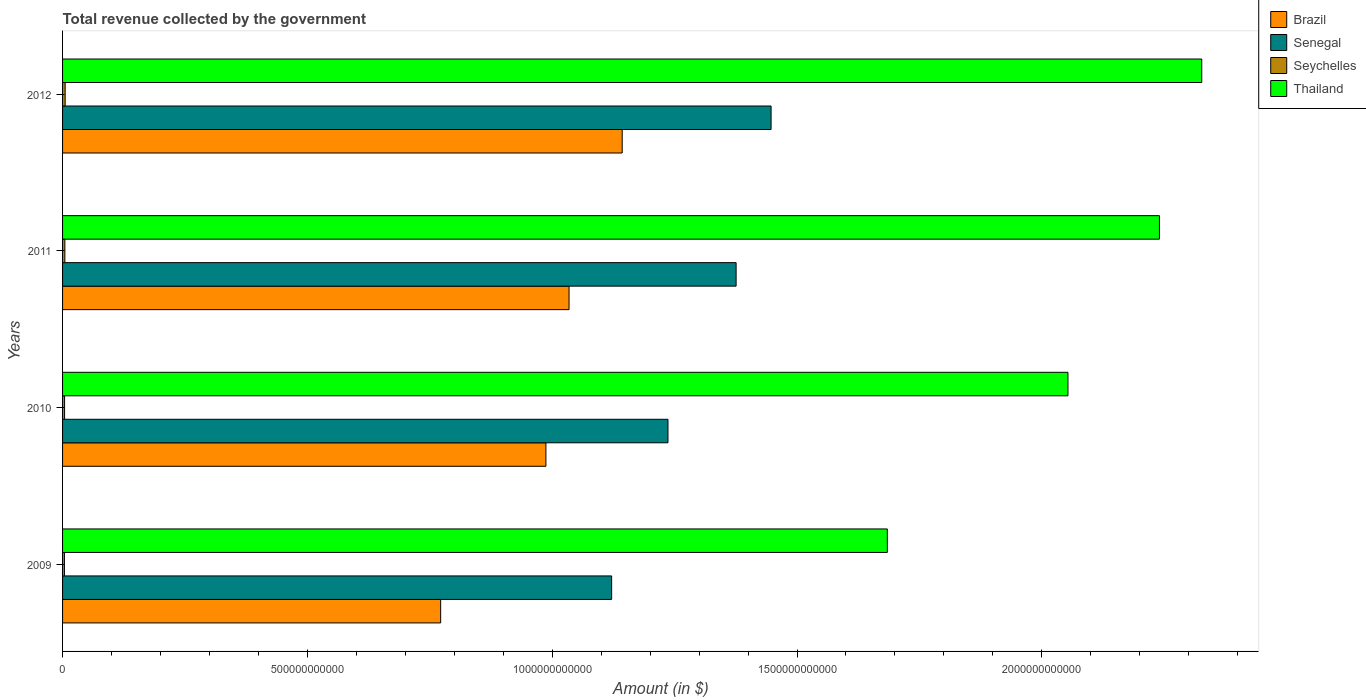How many different coloured bars are there?
Your response must be concise. 4. Are the number of bars on each tick of the Y-axis equal?
Give a very brief answer. Yes. How many bars are there on the 3rd tick from the bottom?
Provide a succinct answer. 4. What is the label of the 3rd group of bars from the top?
Offer a very short reply. 2010. What is the total revenue collected by the government in Thailand in 2012?
Your answer should be very brief. 2.33e+12. Across all years, what is the maximum total revenue collected by the government in Senegal?
Provide a succinct answer. 1.45e+12. Across all years, what is the minimum total revenue collected by the government in Brazil?
Your answer should be compact. 7.72e+11. In which year was the total revenue collected by the government in Seychelles maximum?
Give a very brief answer. 2012. What is the total total revenue collected by the government in Senegal in the graph?
Your answer should be very brief. 5.18e+12. What is the difference between the total revenue collected by the government in Senegal in 2011 and that in 2012?
Give a very brief answer. -7.14e+1. What is the difference between the total revenue collected by the government in Senegal in 2009 and the total revenue collected by the government in Thailand in 2012?
Make the answer very short. -1.21e+12. What is the average total revenue collected by the government in Thailand per year?
Your response must be concise. 2.08e+12. In the year 2009, what is the difference between the total revenue collected by the government in Seychelles and total revenue collected by the government in Thailand?
Your answer should be very brief. -1.68e+12. In how many years, is the total revenue collected by the government in Brazil greater than 200000000000 $?
Keep it short and to the point. 4. What is the ratio of the total revenue collected by the government in Senegal in 2010 to that in 2012?
Ensure brevity in your answer.  0.85. Is the total revenue collected by the government in Seychelles in 2009 less than that in 2012?
Provide a succinct answer. Yes. Is the difference between the total revenue collected by the government in Seychelles in 2010 and 2011 greater than the difference between the total revenue collected by the government in Thailand in 2010 and 2011?
Provide a short and direct response. Yes. What is the difference between the highest and the second highest total revenue collected by the government in Brazil?
Offer a terse response. 1.09e+11. What is the difference between the highest and the lowest total revenue collected by the government in Thailand?
Your response must be concise. 6.42e+11. In how many years, is the total revenue collected by the government in Brazil greater than the average total revenue collected by the government in Brazil taken over all years?
Offer a very short reply. 3. Is it the case that in every year, the sum of the total revenue collected by the government in Thailand and total revenue collected by the government in Brazil is greater than the sum of total revenue collected by the government in Seychelles and total revenue collected by the government in Senegal?
Give a very brief answer. No. What does the 2nd bar from the top in 2012 represents?
Make the answer very short. Seychelles. What does the 3rd bar from the bottom in 2011 represents?
Your response must be concise. Seychelles. Is it the case that in every year, the sum of the total revenue collected by the government in Senegal and total revenue collected by the government in Thailand is greater than the total revenue collected by the government in Seychelles?
Ensure brevity in your answer.  Yes. How many years are there in the graph?
Give a very brief answer. 4. What is the difference between two consecutive major ticks on the X-axis?
Make the answer very short. 5.00e+11. Are the values on the major ticks of X-axis written in scientific E-notation?
Your answer should be very brief. No. Does the graph contain any zero values?
Your answer should be compact. No. How many legend labels are there?
Provide a short and direct response. 4. What is the title of the graph?
Ensure brevity in your answer.  Total revenue collected by the government. Does "Dominican Republic" appear as one of the legend labels in the graph?
Your answer should be very brief. No. What is the label or title of the X-axis?
Give a very brief answer. Amount (in $). What is the Amount (in $) in Brazil in 2009?
Provide a short and direct response. 7.72e+11. What is the Amount (in $) in Senegal in 2009?
Offer a very short reply. 1.12e+12. What is the Amount (in $) of Seychelles in 2009?
Your response must be concise. 3.81e+09. What is the Amount (in $) in Thailand in 2009?
Your answer should be compact. 1.68e+12. What is the Amount (in $) of Brazil in 2010?
Give a very brief answer. 9.87e+11. What is the Amount (in $) in Senegal in 2010?
Offer a very short reply. 1.24e+12. What is the Amount (in $) in Seychelles in 2010?
Your response must be concise. 4.11e+09. What is the Amount (in $) of Thailand in 2010?
Provide a short and direct response. 2.05e+12. What is the Amount (in $) in Brazil in 2011?
Your answer should be very brief. 1.03e+12. What is the Amount (in $) of Senegal in 2011?
Your response must be concise. 1.38e+12. What is the Amount (in $) in Seychelles in 2011?
Give a very brief answer. 4.69e+09. What is the Amount (in $) in Thailand in 2011?
Offer a terse response. 2.24e+12. What is the Amount (in $) in Brazil in 2012?
Your response must be concise. 1.14e+12. What is the Amount (in $) in Senegal in 2012?
Provide a short and direct response. 1.45e+12. What is the Amount (in $) in Seychelles in 2012?
Provide a short and direct response. 5.30e+09. What is the Amount (in $) in Thailand in 2012?
Your response must be concise. 2.33e+12. Across all years, what is the maximum Amount (in $) in Brazil?
Give a very brief answer. 1.14e+12. Across all years, what is the maximum Amount (in $) in Senegal?
Give a very brief answer. 1.45e+12. Across all years, what is the maximum Amount (in $) in Seychelles?
Keep it short and to the point. 5.30e+09. Across all years, what is the maximum Amount (in $) of Thailand?
Provide a short and direct response. 2.33e+12. Across all years, what is the minimum Amount (in $) in Brazil?
Offer a terse response. 7.72e+11. Across all years, what is the minimum Amount (in $) of Senegal?
Give a very brief answer. 1.12e+12. Across all years, what is the minimum Amount (in $) in Seychelles?
Give a very brief answer. 3.81e+09. Across all years, what is the minimum Amount (in $) of Thailand?
Make the answer very short. 1.68e+12. What is the total Amount (in $) in Brazil in the graph?
Provide a short and direct response. 3.94e+12. What is the total Amount (in $) of Senegal in the graph?
Offer a very short reply. 5.18e+12. What is the total Amount (in $) in Seychelles in the graph?
Keep it short and to the point. 1.79e+1. What is the total Amount (in $) in Thailand in the graph?
Keep it short and to the point. 8.30e+12. What is the difference between the Amount (in $) in Brazil in 2009 and that in 2010?
Provide a short and direct response. -2.15e+11. What is the difference between the Amount (in $) in Senegal in 2009 and that in 2010?
Your response must be concise. -1.15e+11. What is the difference between the Amount (in $) of Seychelles in 2009 and that in 2010?
Keep it short and to the point. -3.04e+08. What is the difference between the Amount (in $) of Thailand in 2009 and that in 2010?
Make the answer very short. -3.69e+11. What is the difference between the Amount (in $) in Brazil in 2009 and that in 2011?
Give a very brief answer. -2.62e+11. What is the difference between the Amount (in $) of Senegal in 2009 and that in 2011?
Your response must be concise. -2.54e+11. What is the difference between the Amount (in $) of Seychelles in 2009 and that in 2011?
Make the answer very short. -8.79e+08. What is the difference between the Amount (in $) of Thailand in 2009 and that in 2011?
Provide a succinct answer. -5.56e+11. What is the difference between the Amount (in $) of Brazil in 2009 and that in 2012?
Keep it short and to the point. -3.71e+11. What is the difference between the Amount (in $) in Senegal in 2009 and that in 2012?
Offer a terse response. -3.26e+11. What is the difference between the Amount (in $) of Seychelles in 2009 and that in 2012?
Your response must be concise. -1.49e+09. What is the difference between the Amount (in $) in Thailand in 2009 and that in 2012?
Offer a terse response. -6.42e+11. What is the difference between the Amount (in $) of Brazil in 2010 and that in 2011?
Your response must be concise. -4.72e+1. What is the difference between the Amount (in $) of Senegal in 2010 and that in 2011?
Keep it short and to the point. -1.39e+11. What is the difference between the Amount (in $) in Seychelles in 2010 and that in 2011?
Your response must be concise. -5.75e+08. What is the difference between the Amount (in $) in Thailand in 2010 and that in 2011?
Provide a short and direct response. -1.87e+11. What is the difference between the Amount (in $) of Brazil in 2010 and that in 2012?
Your response must be concise. -1.56e+11. What is the difference between the Amount (in $) in Senegal in 2010 and that in 2012?
Keep it short and to the point. -2.11e+11. What is the difference between the Amount (in $) in Seychelles in 2010 and that in 2012?
Your answer should be very brief. -1.19e+09. What is the difference between the Amount (in $) in Thailand in 2010 and that in 2012?
Keep it short and to the point. -2.73e+11. What is the difference between the Amount (in $) of Brazil in 2011 and that in 2012?
Offer a terse response. -1.09e+11. What is the difference between the Amount (in $) of Senegal in 2011 and that in 2012?
Your answer should be very brief. -7.14e+1. What is the difference between the Amount (in $) in Seychelles in 2011 and that in 2012?
Keep it short and to the point. -6.15e+08. What is the difference between the Amount (in $) in Thailand in 2011 and that in 2012?
Make the answer very short. -8.64e+1. What is the difference between the Amount (in $) of Brazil in 2009 and the Amount (in $) of Senegal in 2010?
Your answer should be very brief. -4.64e+11. What is the difference between the Amount (in $) in Brazil in 2009 and the Amount (in $) in Seychelles in 2010?
Keep it short and to the point. 7.68e+11. What is the difference between the Amount (in $) in Brazil in 2009 and the Amount (in $) in Thailand in 2010?
Give a very brief answer. -1.28e+12. What is the difference between the Amount (in $) of Senegal in 2009 and the Amount (in $) of Seychelles in 2010?
Give a very brief answer. 1.12e+12. What is the difference between the Amount (in $) in Senegal in 2009 and the Amount (in $) in Thailand in 2010?
Ensure brevity in your answer.  -9.32e+11. What is the difference between the Amount (in $) of Seychelles in 2009 and the Amount (in $) of Thailand in 2010?
Offer a terse response. -2.05e+12. What is the difference between the Amount (in $) in Brazil in 2009 and the Amount (in $) in Senegal in 2011?
Keep it short and to the point. -6.03e+11. What is the difference between the Amount (in $) of Brazil in 2009 and the Amount (in $) of Seychelles in 2011?
Your answer should be very brief. 7.67e+11. What is the difference between the Amount (in $) of Brazil in 2009 and the Amount (in $) of Thailand in 2011?
Offer a very short reply. -1.47e+12. What is the difference between the Amount (in $) in Senegal in 2009 and the Amount (in $) in Seychelles in 2011?
Your response must be concise. 1.12e+12. What is the difference between the Amount (in $) in Senegal in 2009 and the Amount (in $) in Thailand in 2011?
Ensure brevity in your answer.  -1.12e+12. What is the difference between the Amount (in $) in Seychelles in 2009 and the Amount (in $) in Thailand in 2011?
Keep it short and to the point. -2.24e+12. What is the difference between the Amount (in $) of Brazil in 2009 and the Amount (in $) of Senegal in 2012?
Keep it short and to the point. -6.75e+11. What is the difference between the Amount (in $) of Brazil in 2009 and the Amount (in $) of Seychelles in 2012?
Give a very brief answer. 7.67e+11. What is the difference between the Amount (in $) in Brazil in 2009 and the Amount (in $) in Thailand in 2012?
Offer a very short reply. -1.55e+12. What is the difference between the Amount (in $) in Senegal in 2009 and the Amount (in $) in Seychelles in 2012?
Give a very brief answer. 1.12e+12. What is the difference between the Amount (in $) in Senegal in 2009 and the Amount (in $) in Thailand in 2012?
Ensure brevity in your answer.  -1.21e+12. What is the difference between the Amount (in $) of Seychelles in 2009 and the Amount (in $) of Thailand in 2012?
Keep it short and to the point. -2.32e+12. What is the difference between the Amount (in $) in Brazil in 2010 and the Amount (in $) in Senegal in 2011?
Your answer should be compact. -3.88e+11. What is the difference between the Amount (in $) of Brazil in 2010 and the Amount (in $) of Seychelles in 2011?
Ensure brevity in your answer.  9.82e+11. What is the difference between the Amount (in $) in Brazil in 2010 and the Amount (in $) in Thailand in 2011?
Your answer should be very brief. -1.25e+12. What is the difference between the Amount (in $) in Senegal in 2010 and the Amount (in $) in Seychelles in 2011?
Your answer should be compact. 1.23e+12. What is the difference between the Amount (in $) in Senegal in 2010 and the Amount (in $) in Thailand in 2011?
Keep it short and to the point. -1.00e+12. What is the difference between the Amount (in $) in Seychelles in 2010 and the Amount (in $) in Thailand in 2011?
Offer a terse response. -2.24e+12. What is the difference between the Amount (in $) in Brazil in 2010 and the Amount (in $) in Senegal in 2012?
Offer a very short reply. -4.60e+11. What is the difference between the Amount (in $) in Brazil in 2010 and the Amount (in $) in Seychelles in 2012?
Provide a short and direct response. 9.82e+11. What is the difference between the Amount (in $) of Brazil in 2010 and the Amount (in $) of Thailand in 2012?
Offer a terse response. -1.34e+12. What is the difference between the Amount (in $) in Senegal in 2010 and the Amount (in $) in Seychelles in 2012?
Offer a terse response. 1.23e+12. What is the difference between the Amount (in $) of Senegal in 2010 and the Amount (in $) of Thailand in 2012?
Provide a short and direct response. -1.09e+12. What is the difference between the Amount (in $) of Seychelles in 2010 and the Amount (in $) of Thailand in 2012?
Offer a very short reply. -2.32e+12. What is the difference between the Amount (in $) in Brazil in 2011 and the Amount (in $) in Senegal in 2012?
Keep it short and to the point. -4.13e+11. What is the difference between the Amount (in $) in Brazil in 2011 and the Amount (in $) in Seychelles in 2012?
Provide a succinct answer. 1.03e+12. What is the difference between the Amount (in $) in Brazil in 2011 and the Amount (in $) in Thailand in 2012?
Offer a terse response. -1.29e+12. What is the difference between the Amount (in $) of Senegal in 2011 and the Amount (in $) of Seychelles in 2012?
Offer a very short reply. 1.37e+12. What is the difference between the Amount (in $) in Senegal in 2011 and the Amount (in $) in Thailand in 2012?
Offer a very short reply. -9.51e+11. What is the difference between the Amount (in $) in Seychelles in 2011 and the Amount (in $) in Thailand in 2012?
Make the answer very short. -2.32e+12. What is the average Amount (in $) in Brazil per year?
Your answer should be very brief. 9.84e+11. What is the average Amount (in $) of Senegal per year?
Your answer should be very brief. 1.30e+12. What is the average Amount (in $) in Seychelles per year?
Keep it short and to the point. 4.48e+09. What is the average Amount (in $) of Thailand per year?
Offer a very short reply. 2.08e+12. In the year 2009, what is the difference between the Amount (in $) of Brazil and Amount (in $) of Senegal?
Keep it short and to the point. -3.49e+11. In the year 2009, what is the difference between the Amount (in $) of Brazil and Amount (in $) of Seychelles?
Your response must be concise. 7.68e+11. In the year 2009, what is the difference between the Amount (in $) of Brazil and Amount (in $) of Thailand?
Your answer should be compact. -9.12e+11. In the year 2009, what is the difference between the Amount (in $) of Senegal and Amount (in $) of Seychelles?
Offer a very short reply. 1.12e+12. In the year 2009, what is the difference between the Amount (in $) of Senegal and Amount (in $) of Thailand?
Give a very brief answer. -5.63e+11. In the year 2009, what is the difference between the Amount (in $) of Seychelles and Amount (in $) of Thailand?
Your answer should be very brief. -1.68e+12. In the year 2010, what is the difference between the Amount (in $) of Brazil and Amount (in $) of Senegal?
Make the answer very short. -2.49e+11. In the year 2010, what is the difference between the Amount (in $) in Brazil and Amount (in $) in Seychelles?
Provide a short and direct response. 9.83e+11. In the year 2010, what is the difference between the Amount (in $) of Brazil and Amount (in $) of Thailand?
Provide a short and direct response. -1.07e+12. In the year 2010, what is the difference between the Amount (in $) of Senegal and Amount (in $) of Seychelles?
Provide a short and direct response. 1.23e+12. In the year 2010, what is the difference between the Amount (in $) of Senegal and Amount (in $) of Thailand?
Ensure brevity in your answer.  -8.17e+11. In the year 2010, what is the difference between the Amount (in $) in Seychelles and Amount (in $) in Thailand?
Make the answer very short. -2.05e+12. In the year 2011, what is the difference between the Amount (in $) of Brazil and Amount (in $) of Senegal?
Give a very brief answer. -3.41e+11. In the year 2011, what is the difference between the Amount (in $) in Brazil and Amount (in $) in Seychelles?
Offer a terse response. 1.03e+12. In the year 2011, what is the difference between the Amount (in $) in Brazil and Amount (in $) in Thailand?
Provide a short and direct response. -1.21e+12. In the year 2011, what is the difference between the Amount (in $) in Senegal and Amount (in $) in Seychelles?
Your response must be concise. 1.37e+12. In the year 2011, what is the difference between the Amount (in $) of Senegal and Amount (in $) of Thailand?
Offer a very short reply. -8.65e+11. In the year 2011, what is the difference between the Amount (in $) of Seychelles and Amount (in $) of Thailand?
Give a very brief answer. -2.24e+12. In the year 2012, what is the difference between the Amount (in $) in Brazil and Amount (in $) in Senegal?
Offer a very short reply. -3.04e+11. In the year 2012, what is the difference between the Amount (in $) in Brazil and Amount (in $) in Seychelles?
Keep it short and to the point. 1.14e+12. In the year 2012, what is the difference between the Amount (in $) of Brazil and Amount (in $) of Thailand?
Provide a succinct answer. -1.18e+12. In the year 2012, what is the difference between the Amount (in $) in Senegal and Amount (in $) in Seychelles?
Ensure brevity in your answer.  1.44e+12. In the year 2012, what is the difference between the Amount (in $) in Senegal and Amount (in $) in Thailand?
Your response must be concise. -8.80e+11. In the year 2012, what is the difference between the Amount (in $) of Seychelles and Amount (in $) of Thailand?
Provide a short and direct response. -2.32e+12. What is the ratio of the Amount (in $) of Brazil in 2009 to that in 2010?
Offer a terse response. 0.78. What is the ratio of the Amount (in $) of Senegal in 2009 to that in 2010?
Your response must be concise. 0.91. What is the ratio of the Amount (in $) in Seychelles in 2009 to that in 2010?
Make the answer very short. 0.93. What is the ratio of the Amount (in $) of Thailand in 2009 to that in 2010?
Make the answer very short. 0.82. What is the ratio of the Amount (in $) in Brazil in 2009 to that in 2011?
Keep it short and to the point. 0.75. What is the ratio of the Amount (in $) in Senegal in 2009 to that in 2011?
Your answer should be compact. 0.82. What is the ratio of the Amount (in $) of Seychelles in 2009 to that in 2011?
Your answer should be compact. 0.81. What is the ratio of the Amount (in $) of Thailand in 2009 to that in 2011?
Your answer should be very brief. 0.75. What is the ratio of the Amount (in $) of Brazil in 2009 to that in 2012?
Provide a short and direct response. 0.68. What is the ratio of the Amount (in $) of Senegal in 2009 to that in 2012?
Keep it short and to the point. 0.78. What is the ratio of the Amount (in $) in Seychelles in 2009 to that in 2012?
Offer a terse response. 0.72. What is the ratio of the Amount (in $) of Thailand in 2009 to that in 2012?
Your answer should be compact. 0.72. What is the ratio of the Amount (in $) of Brazil in 2010 to that in 2011?
Keep it short and to the point. 0.95. What is the ratio of the Amount (in $) in Senegal in 2010 to that in 2011?
Ensure brevity in your answer.  0.9. What is the ratio of the Amount (in $) in Seychelles in 2010 to that in 2011?
Your response must be concise. 0.88. What is the ratio of the Amount (in $) in Thailand in 2010 to that in 2011?
Keep it short and to the point. 0.92. What is the ratio of the Amount (in $) in Brazil in 2010 to that in 2012?
Your answer should be very brief. 0.86. What is the ratio of the Amount (in $) in Senegal in 2010 to that in 2012?
Offer a terse response. 0.85. What is the ratio of the Amount (in $) in Seychelles in 2010 to that in 2012?
Make the answer very short. 0.78. What is the ratio of the Amount (in $) in Thailand in 2010 to that in 2012?
Your answer should be compact. 0.88. What is the ratio of the Amount (in $) of Brazil in 2011 to that in 2012?
Offer a very short reply. 0.91. What is the ratio of the Amount (in $) of Senegal in 2011 to that in 2012?
Make the answer very short. 0.95. What is the ratio of the Amount (in $) in Seychelles in 2011 to that in 2012?
Give a very brief answer. 0.88. What is the ratio of the Amount (in $) in Thailand in 2011 to that in 2012?
Give a very brief answer. 0.96. What is the difference between the highest and the second highest Amount (in $) of Brazil?
Your response must be concise. 1.09e+11. What is the difference between the highest and the second highest Amount (in $) of Senegal?
Offer a very short reply. 7.14e+1. What is the difference between the highest and the second highest Amount (in $) in Seychelles?
Make the answer very short. 6.15e+08. What is the difference between the highest and the second highest Amount (in $) of Thailand?
Provide a succinct answer. 8.64e+1. What is the difference between the highest and the lowest Amount (in $) of Brazil?
Provide a short and direct response. 3.71e+11. What is the difference between the highest and the lowest Amount (in $) in Senegal?
Your answer should be compact. 3.26e+11. What is the difference between the highest and the lowest Amount (in $) in Seychelles?
Make the answer very short. 1.49e+09. What is the difference between the highest and the lowest Amount (in $) of Thailand?
Your answer should be very brief. 6.42e+11. 